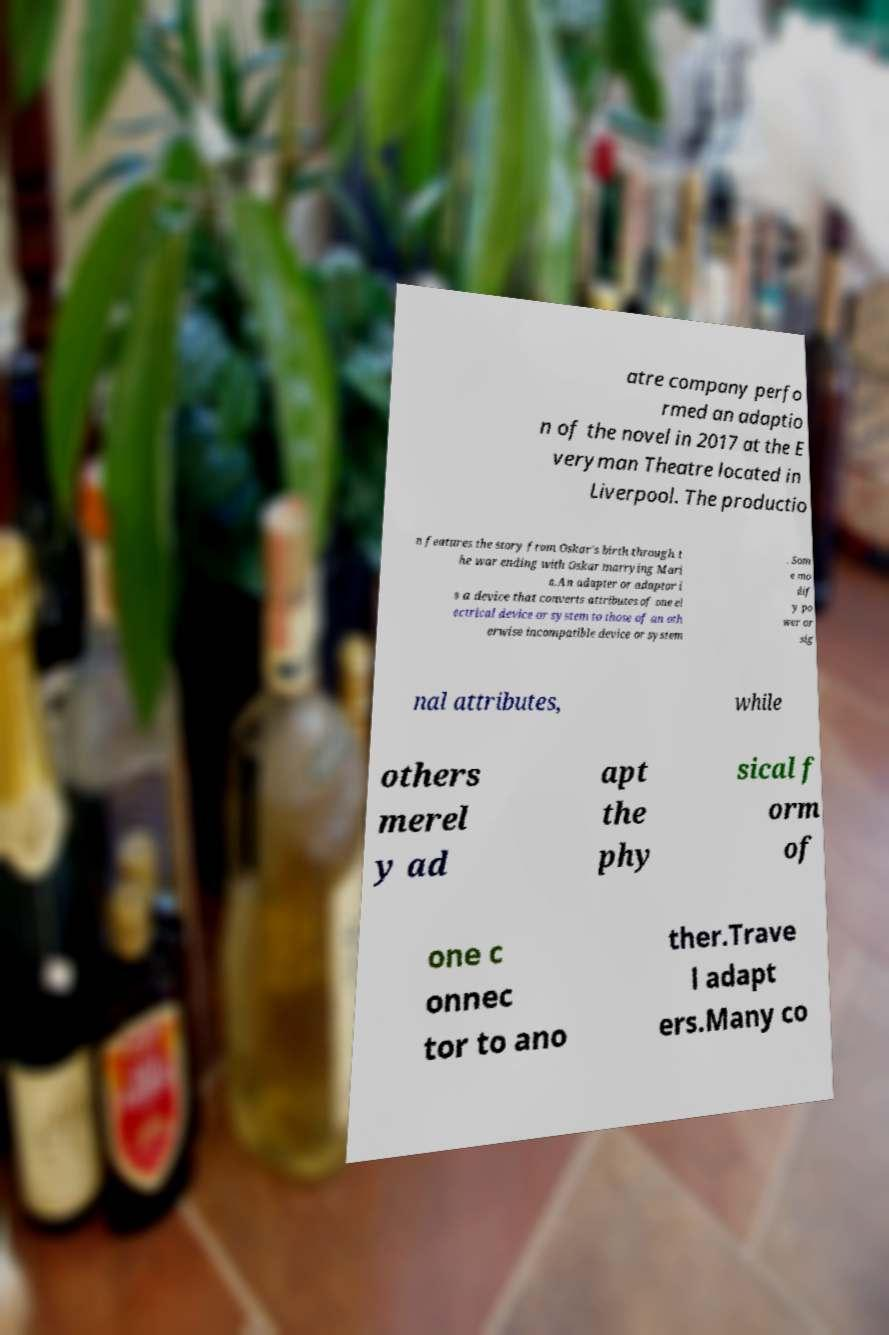Could you extract and type out the text from this image? atre company perfo rmed an adaptio n of the novel in 2017 at the E veryman Theatre located in Liverpool. The productio n features the story from Oskar's birth through t he war ending with Oskar marrying Mari a.An adapter or adaptor i s a device that converts attributes of one el ectrical device or system to those of an oth erwise incompatible device or system . Som e mo dif y po wer or sig nal attributes, while others merel y ad apt the phy sical f orm of one c onnec tor to ano ther.Trave l adapt ers.Many co 